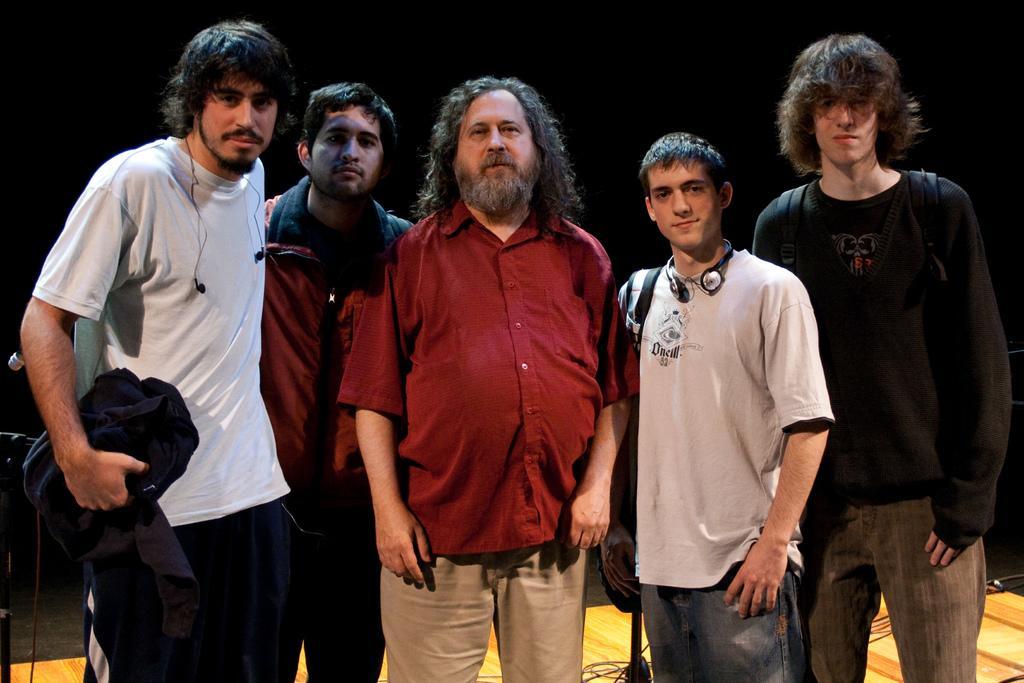In one or two sentences, can you explain what this image depicts? There are five persons in different color dresses, standing. One of them is holding a cloth. And the background is dark in color. 